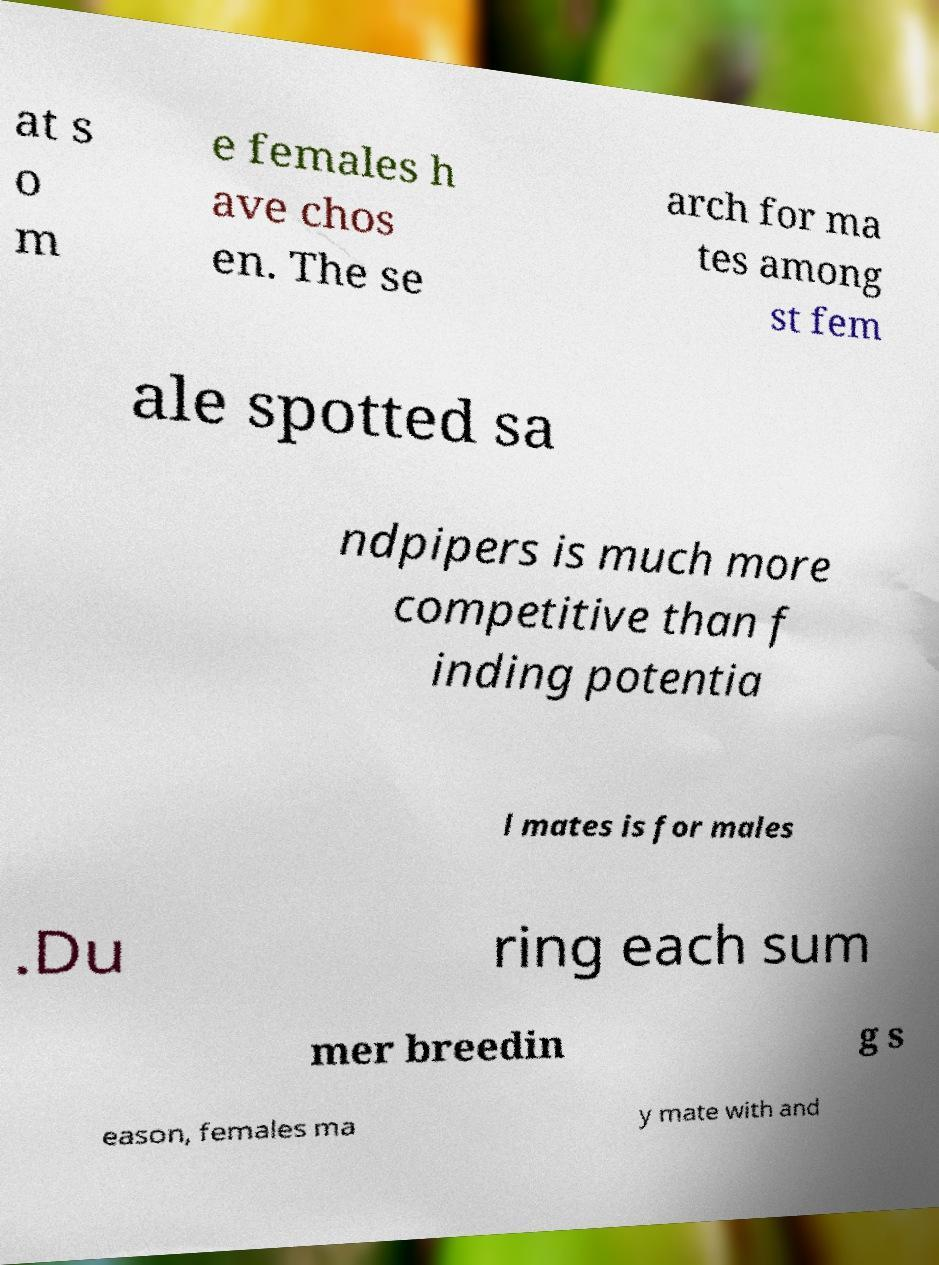What messages or text are displayed in this image? I need them in a readable, typed format. at s o m e females h ave chos en. The se arch for ma tes among st fem ale spotted sa ndpipers is much more competitive than f inding potentia l mates is for males .Du ring each sum mer breedin g s eason, females ma y mate with and 